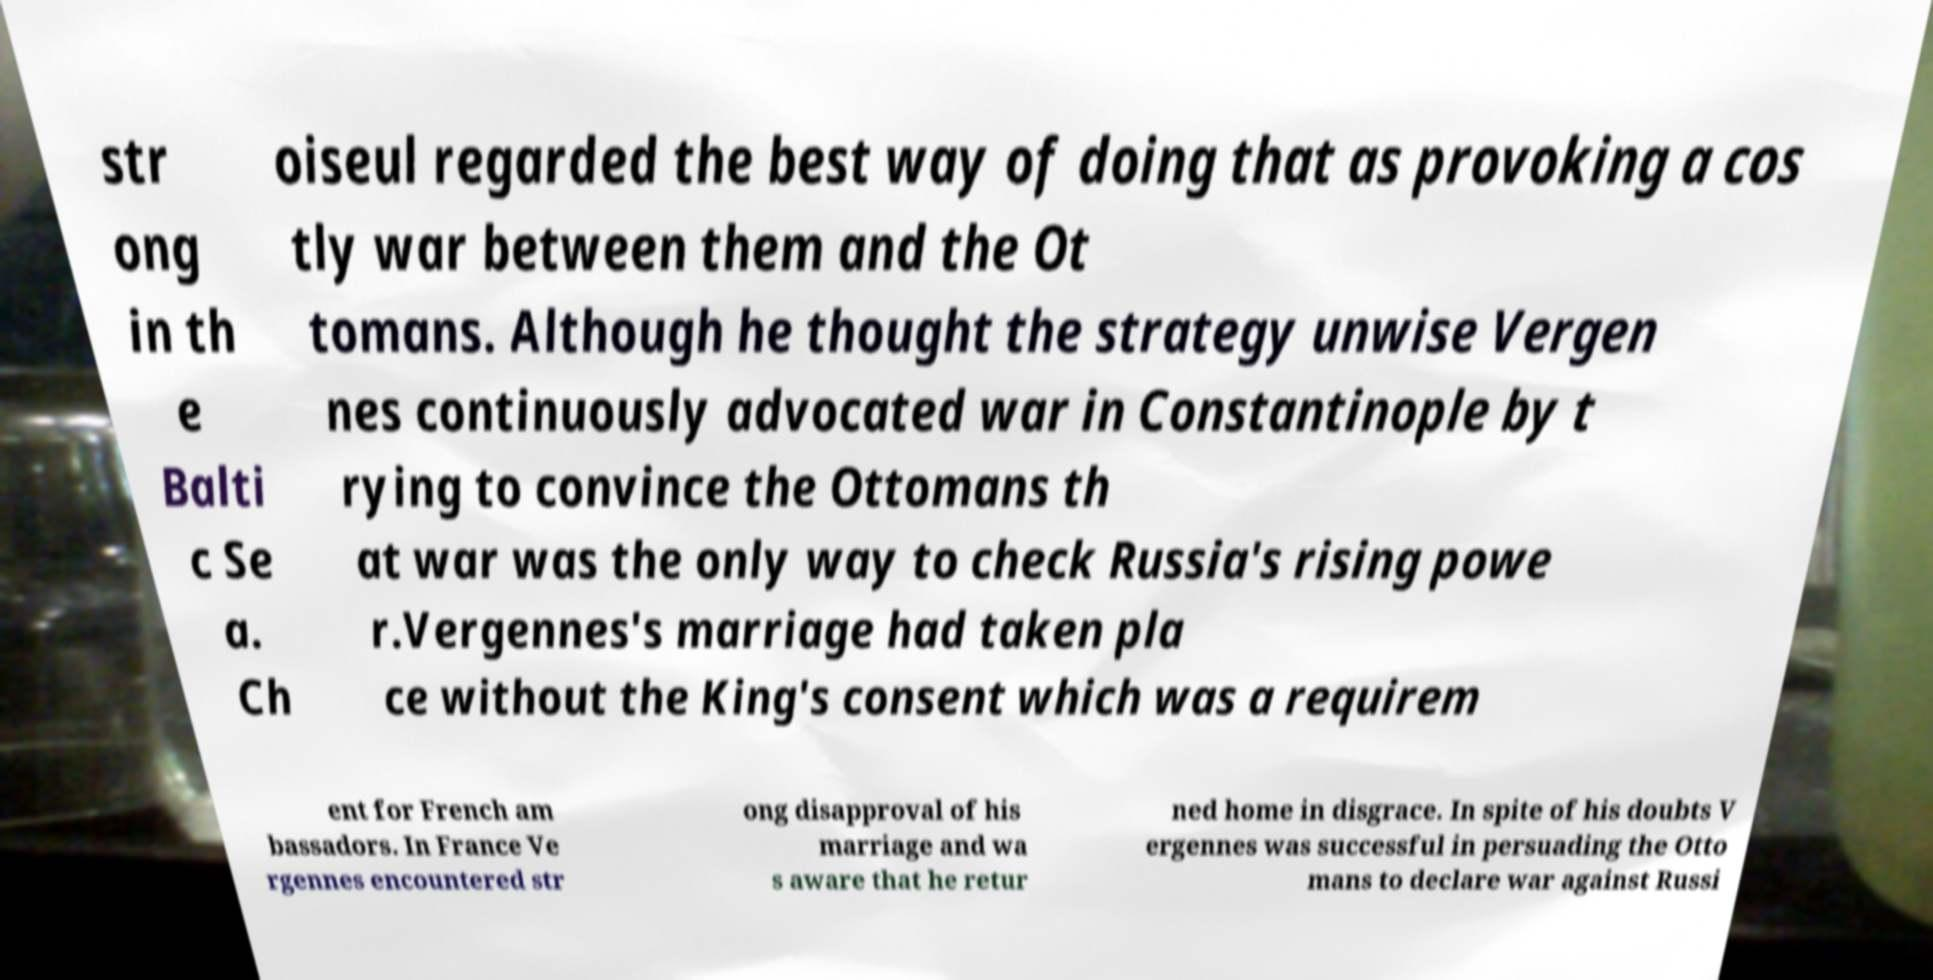Could you extract and type out the text from this image? str ong in th e Balti c Se a. Ch oiseul regarded the best way of doing that as provoking a cos tly war between them and the Ot tomans. Although he thought the strategy unwise Vergen nes continuously advocated war in Constantinople by t rying to convince the Ottomans th at war was the only way to check Russia's rising powe r.Vergennes's marriage had taken pla ce without the King's consent which was a requirem ent for French am bassadors. In France Ve rgennes encountered str ong disapproval of his marriage and wa s aware that he retur ned home in disgrace. In spite of his doubts V ergennes was successful in persuading the Otto mans to declare war against Russi 